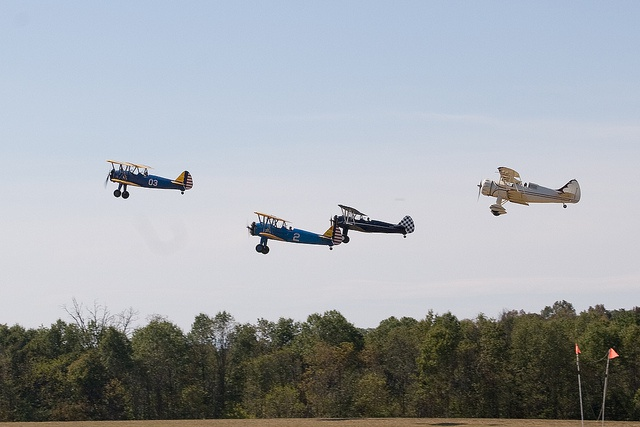Describe the objects in this image and their specific colors. I can see airplane in lavender, gray, darkgray, and lightgray tones, airplane in lavender, black, navy, lightgray, and gray tones, airplane in lavender, navy, black, gray, and lightgray tones, airplane in lavender, black, gray, darkgray, and lightgray tones, and people in lavender, gray, black, and darkgray tones in this image. 